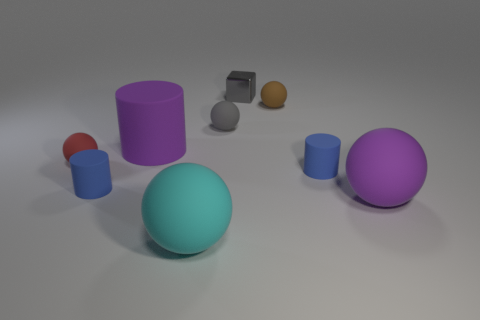Subtract all purple balls. How many balls are left? 4 Subtract all purple cylinders. How many cylinders are left? 2 Subtract all purple spheres. How many blue cylinders are left? 2 Subtract all spheres. How many objects are left? 4 Subtract 2 cylinders. How many cylinders are left? 1 Add 3 tiny gray rubber balls. How many tiny gray rubber balls are left? 4 Add 4 blocks. How many blocks exist? 5 Subtract 2 blue cylinders. How many objects are left? 7 Subtract all cyan balls. Subtract all cyan cubes. How many balls are left? 4 Subtract all rubber cylinders. Subtract all gray cubes. How many objects are left? 5 